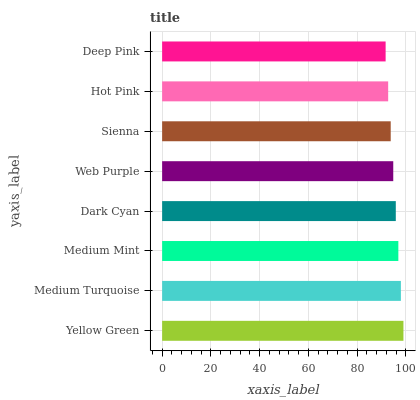Is Deep Pink the minimum?
Answer yes or no. Yes. Is Yellow Green the maximum?
Answer yes or no. Yes. Is Medium Turquoise the minimum?
Answer yes or no. No. Is Medium Turquoise the maximum?
Answer yes or no. No. Is Yellow Green greater than Medium Turquoise?
Answer yes or no. Yes. Is Medium Turquoise less than Yellow Green?
Answer yes or no. Yes. Is Medium Turquoise greater than Yellow Green?
Answer yes or no. No. Is Yellow Green less than Medium Turquoise?
Answer yes or no. No. Is Dark Cyan the high median?
Answer yes or no. Yes. Is Web Purple the low median?
Answer yes or no. Yes. Is Hot Pink the high median?
Answer yes or no. No. Is Dark Cyan the low median?
Answer yes or no. No. 